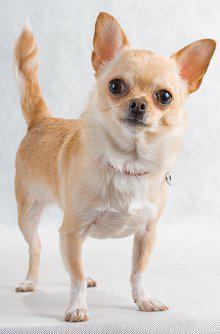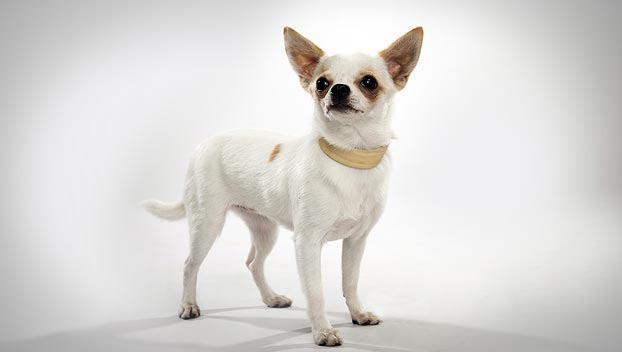The first image is the image on the left, the second image is the image on the right. Considering the images on both sides, is "At least one image shows a small dog standing on green grass." valid? Answer yes or no. No. 